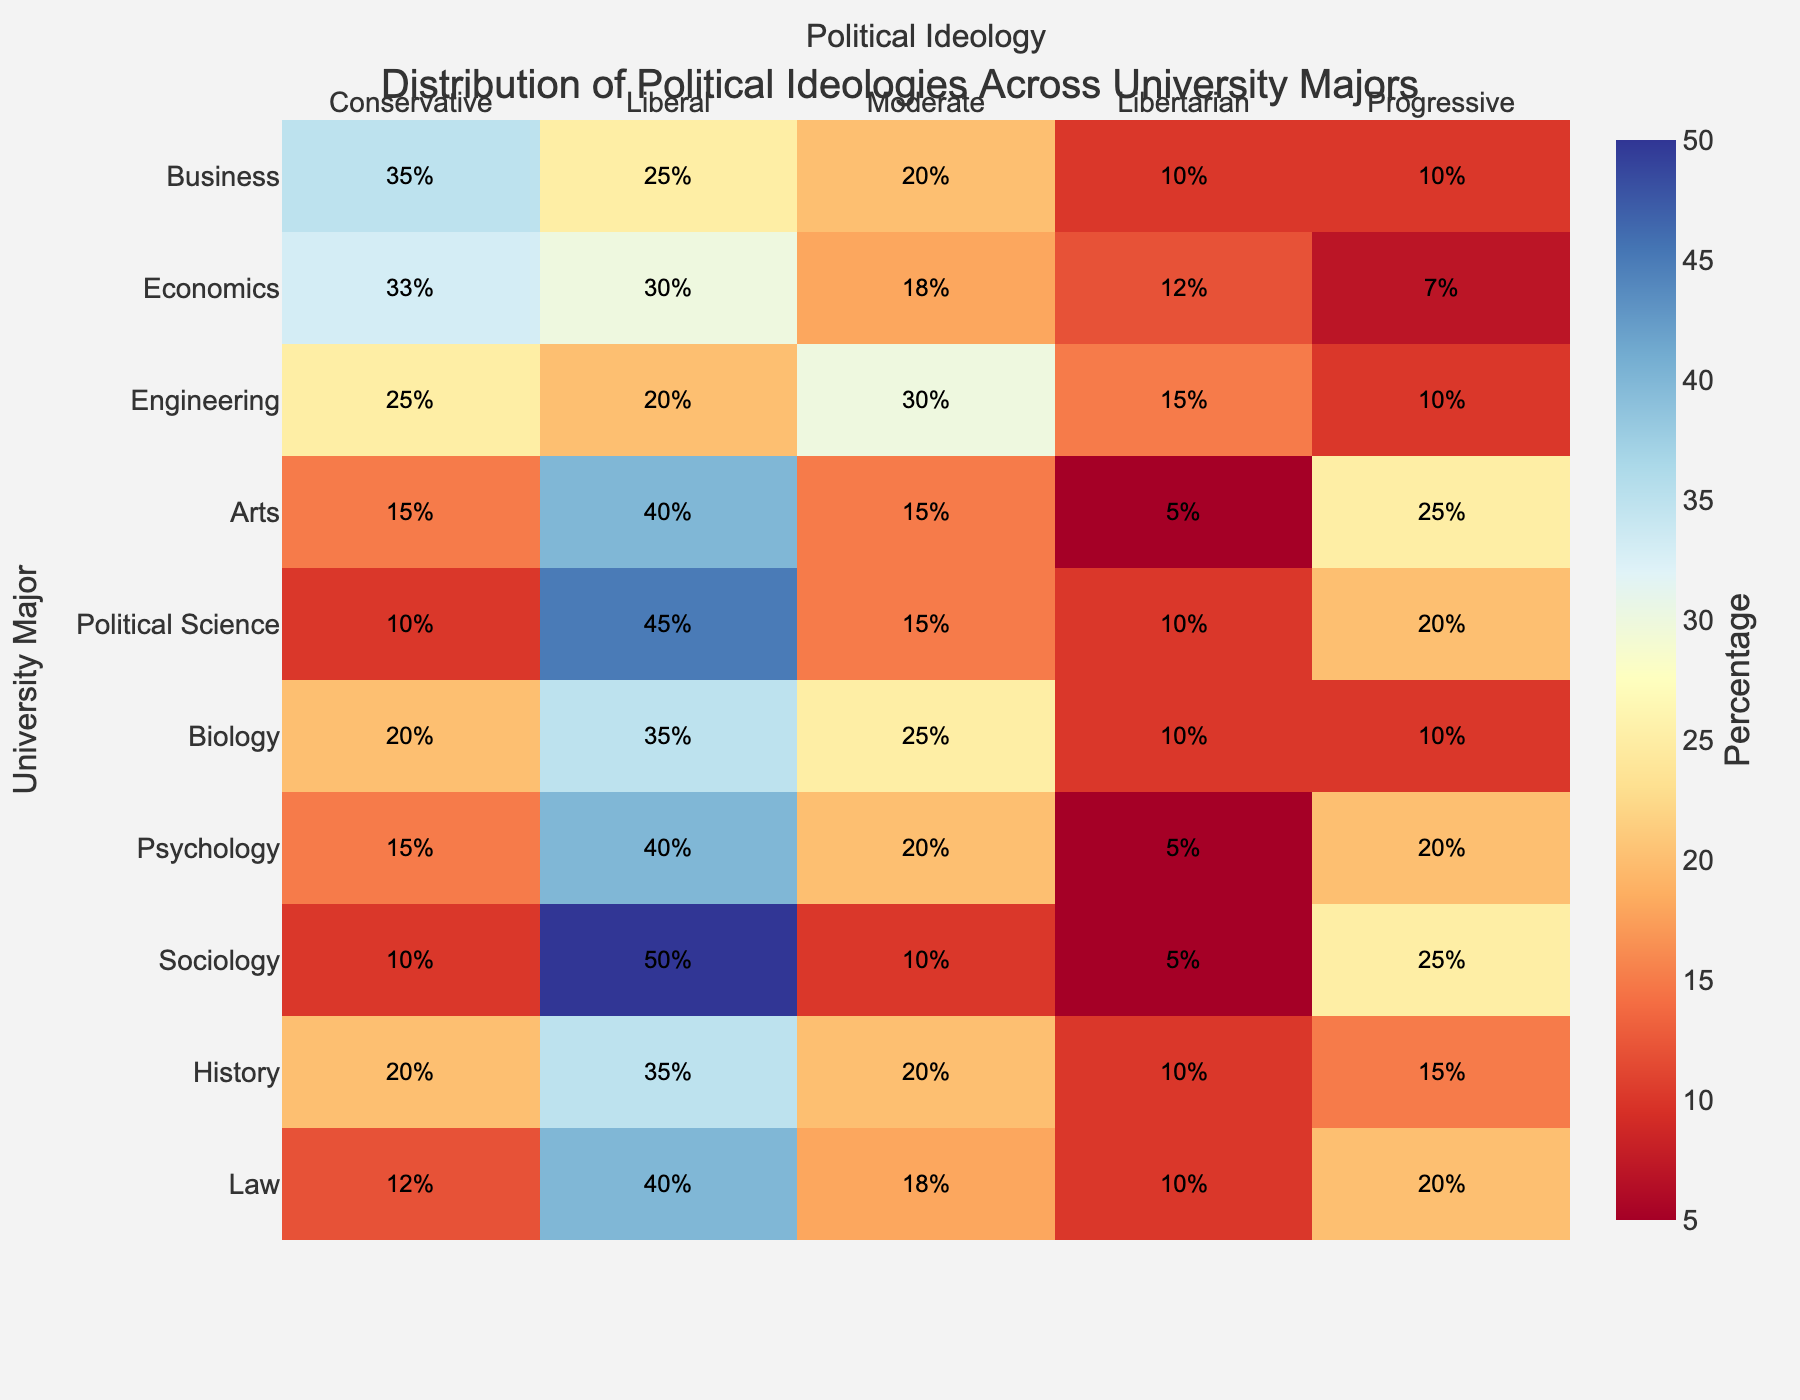What is the title of the heatmap? The title is usually located at the top of the heatmap. It provides context about what the heatmap is representing.
Answer: Distribution of Political Ideologies Across University Majors Which major has the highest percentage of Liberal students? To determine this, look at the Liberal column and find the major with the highest value. In this case, it's Political Science with 45%.
Answer: Political Science How many majors have a higher percentage of Progressive students than Business? Business has 10% Progressive students. Count the number of majors with a value higher than 10% in the Progressive column. These majors are Arts, Political Science, Psychology, Sociology, and History.
Answer: 5 What is the combined percentage of Conservative and Liberal students in the Economics major? Check the percentages for Conservative and Liberal in the Economics row and add them together. The values are 33% and 30%, respectively. Therefore, 33% + 30% = 63%.
Answer: 63% Which ideology has the lowest representation in the Engineering major? Look at the percentages for all ideologies in the Engineering row. The lowest value is for Liberal with 20%.
Answer: Liberal Compare the percentage of Moderate students in Engineering and Biology. Which major has more Moderate students? Check the Moderate column for both majors. Engineering has 30% and Biology has 25%, so Engineering has more.
Answer: Engineering What is the average percentage of Libertarian students across all majors? Add the percentages of Libertarian students in all majors and divide by the number of majors. These values are 10, 12, 15, 5, 10, 10, 5, 5, 10, and 10. Sum is 92. Average is 92/10 = 9.2%.
Answer: 9.2% Which ideology is most prevalent in Sociology? Look at the percentages for all ideologies in the Sociology row. The highest percentage is 50% for Liberal.
Answer: Liberal Is the percentage of Progressive students in Law higher than in History? Check the percentages for Progressive students in both majors. Law has 20% and History has 15%, so Law has a higher percentage.
Answer: Yes What is the total percentage of Conservative students across all majors? Sum the percentages of Conservative students in all majors: 35, 33, 25, 15, 10, 20, 15, 10, 20, and 12. Sum is 195%.
Answer: 195% 